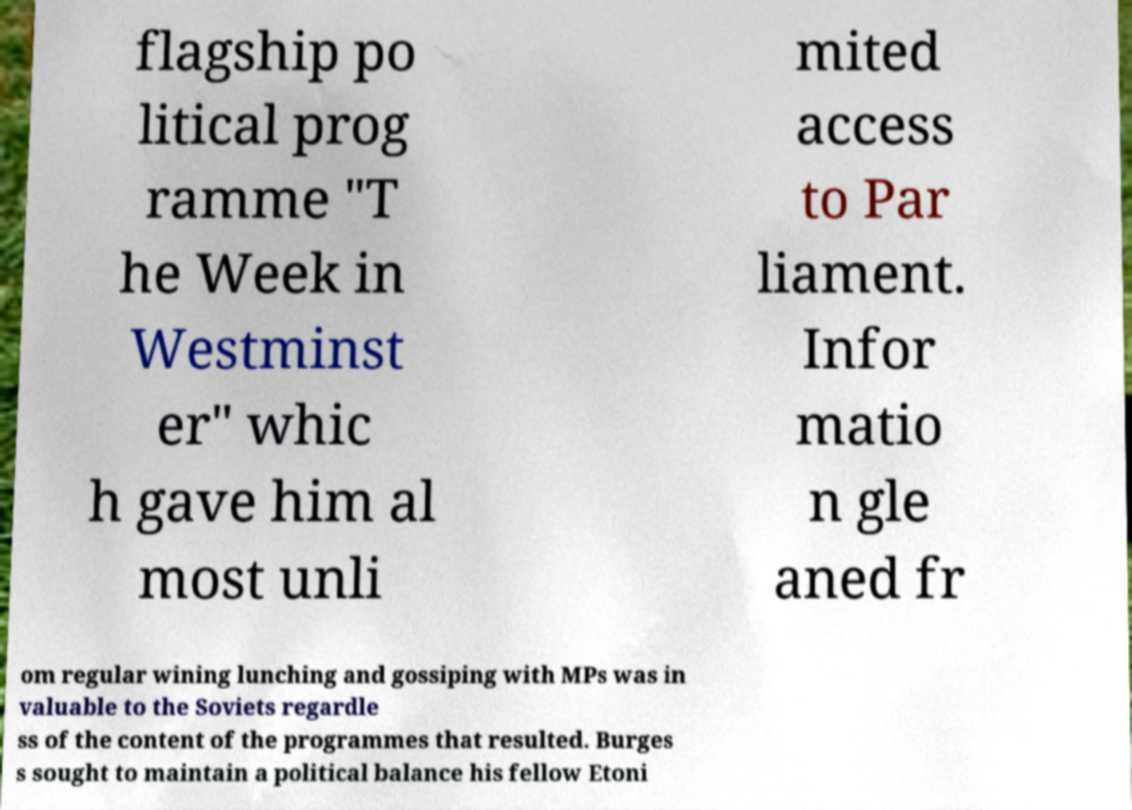Can you read and provide the text displayed in the image?This photo seems to have some interesting text. Can you extract and type it out for me? flagship po litical prog ramme "T he Week in Westminst er" whic h gave him al most unli mited access to Par liament. Infor matio n gle aned fr om regular wining lunching and gossiping with MPs was in valuable to the Soviets regardle ss of the content of the programmes that resulted. Burges s sought to maintain a political balance his fellow Etoni 